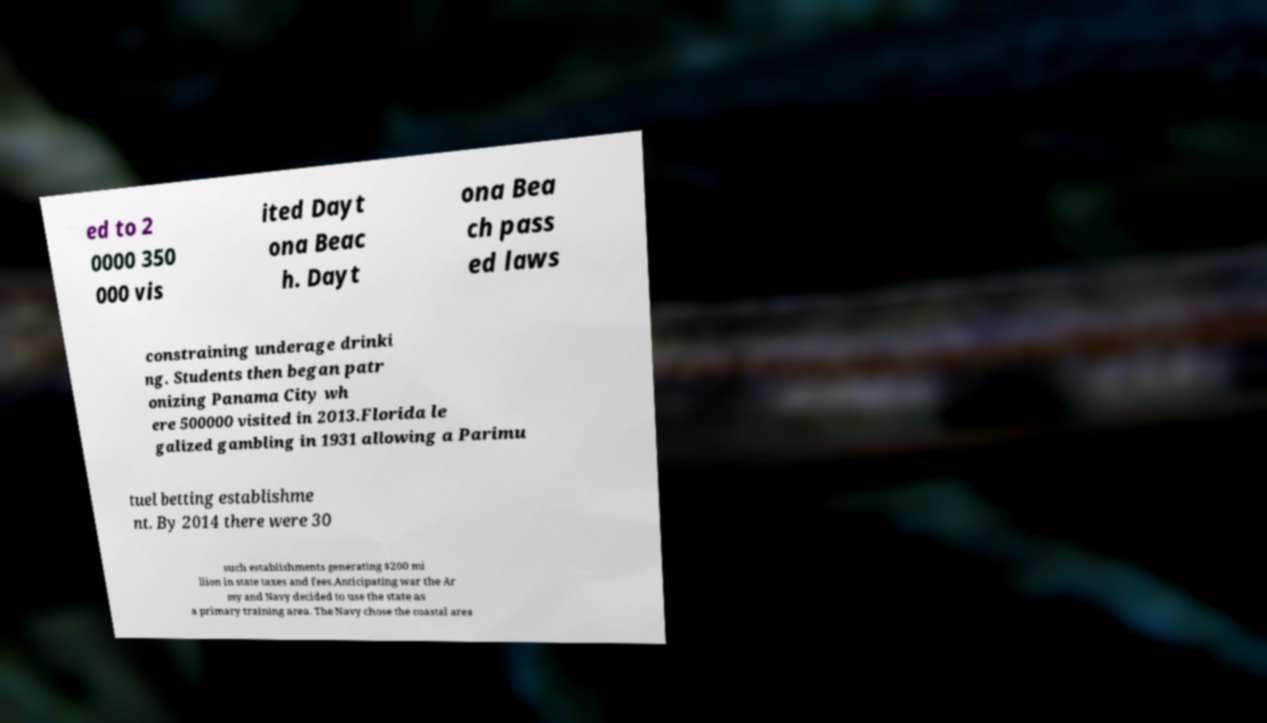Could you extract and type out the text from this image? ed to 2 0000 350 000 vis ited Dayt ona Beac h. Dayt ona Bea ch pass ed laws constraining underage drinki ng. Students then began patr onizing Panama City wh ere 500000 visited in 2013.Florida le galized gambling in 1931 allowing a Parimu tuel betting establishme nt. By 2014 there were 30 such establishments generating $200 mi llion in state taxes and fees.Anticipating war the Ar my and Navy decided to use the state as a primary training area. The Navy chose the coastal area 